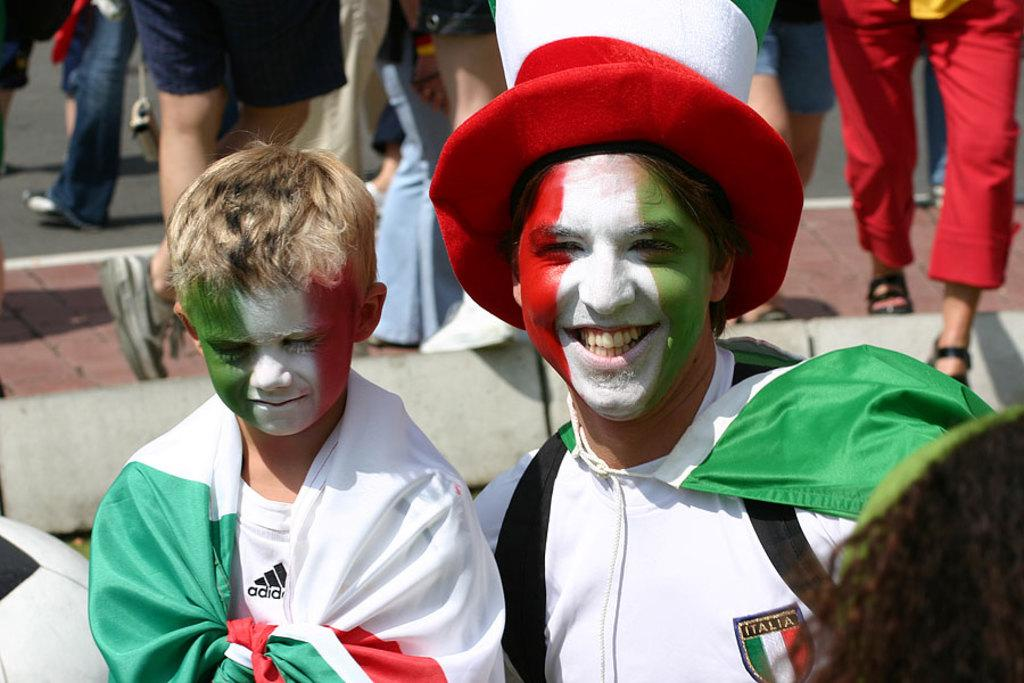What are the people in the image doing? The people in the image are walking on the road. What are the people holding? The people are holding objects. Can you describe the appearance of two people in the image? Two people are painting their faces with flag colors. What is present on the ground in the image? There is an object on the ground in the image. How does the self-awareness of the people in the image affect their actions? The provided facts do not mention anything about self-awareness or its effect on the people's actions in the image. --- Facts: 1. There is a person sitting on a chair in the image. 2. The person is holding a book. 3. The book has a title. 4. The chair is made of wood. 5. The background of the image is a room. Absurd Topics: dance, ocean, parrot Conversation: What is the person in the image doing? The person in the image is sitting on a chair. What is the person holding? The person is holding a book. What can be inferred about the book from the image? The book has a title. What is the chair made of? The chair is made of wood. What is the setting of the image? The background of the image is a room. Reasoning: Let's think step by step in order to produce the conversation. We start by identifying the main subject in the image, which is the person sitting on a chair. Then, we mention the object they are holding, which is a book. Next, we describe a specific detail about the book, which is its title. After that, we identify the material of the chair, which is wood. Finally, we describe the setting of the image, which is a room. Absurd Question/Answer: Can you describe the dance moves the person is performing in the image? There is no indication in the image that the person is dancing or performing any dance moves. --- Facts: 1. There is a person standing near a tree in the image. 2. The person is holding a camera. 3. The tree has leaves. 4. The sky is visible in the image. 5. The person is wearing a hat. Absurd Topics: fire, music, bicycle Conversation: What is the person in the image doing? The person in the image is standing near a tree. What is the person holding? The person is holding a camera. Can you describe the tree in the image? The tree has leaves. What is visible in the background of the image? The sky is visible in the image. What is the person wearing on their head? The person is 